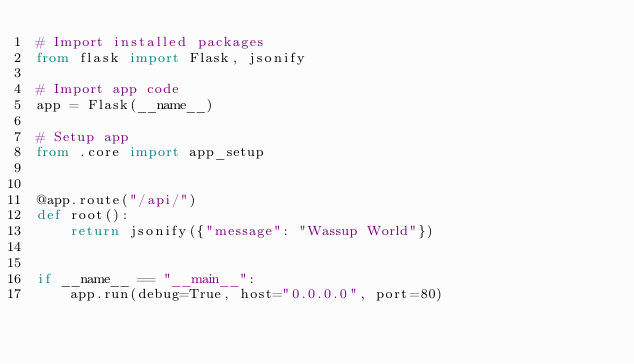Convert code to text. <code><loc_0><loc_0><loc_500><loc_500><_Python_># Import installed packages
from flask import Flask, jsonify

# Import app code
app = Flask(__name__)

# Setup app
from .core import app_setup


@app.route("/api/")
def root():
    return jsonify({"message": "Wassup World"})


if __name__ == "__main__":
    app.run(debug=True, host="0.0.0.0", port=80)
</code> 